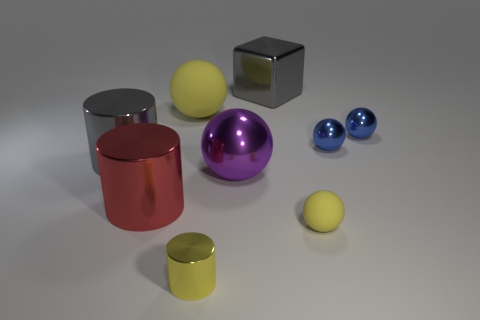Do the small yellow object right of the metal cube and the big yellow sphere have the same material?
Provide a succinct answer. Yes. What material is the big yellow thing?
Offer a terse response. Rubber. There is a yellow matte object in front of the gray metallic cylinder; what size is it?
Offer a terse response. Small. Is there anything else of the same color as the big metallic sphere?
Your answer should be compact. No. There is a large purple object to the left of the yellow sphere on the right side of the large metallic block; is there a small shiny object that is left of it?
Your answer should be very brief. Yes. Do the rubber object that is right of the gray metallic cube and the large metallic cube have the same color?
Ensure brevity in your answer.  No. What number of spheres are blue metal things or large gray metallic things?
Your answer should be very brief. 2. There is a thing on the left side of the big object in front of the large purple thing; what shape is it?
Your response must be concise. Cylinder. What size is the shiny thing in front of the yellow rubber ball to the right of the large sphere behind the large gray cylinder?
Offer a very short reply. Small. Is the red metal thing the same size as the purple sphere?
Make the answer very short. Yes. 